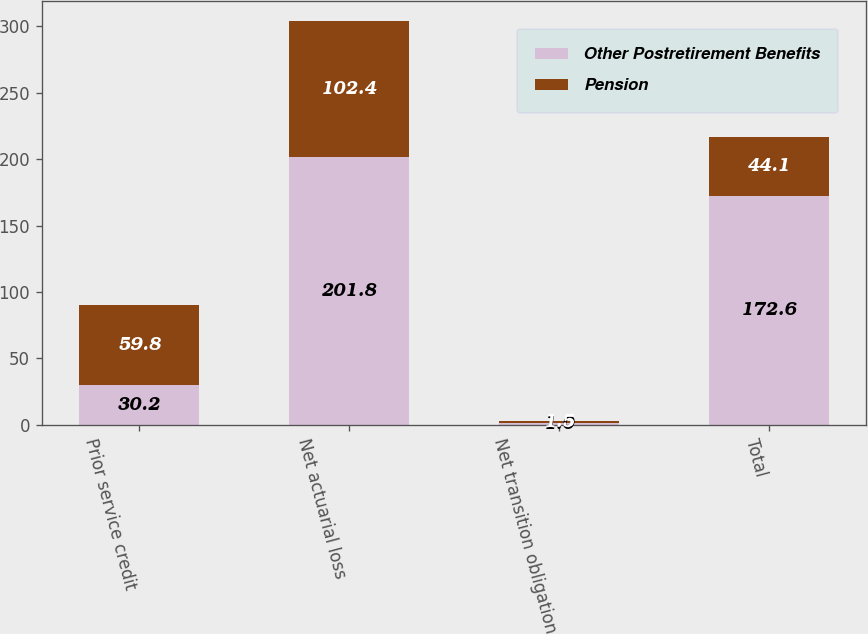Convert chart. <chart><loc_0><loc_0><loc_500><loc_500><stacked_bar_chart><ecel><fcel>Prior service credit<fcel>Net actuarial loss<fcel>Net transition obligation<fcel>Total<nl><fcel>Other Postretirement Benefits<fcel>30.2<fcel>201.8<fcel>1<fcel>172.6<nl><fcel>Pension<fcel>59.8<fcel>102.4<fcel>1.5<fcel>44.1<nl></chart> 